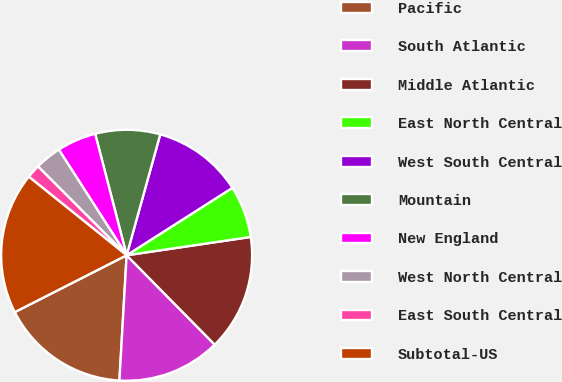Convert chart. <chart><loc_0><loc_0><loc_500><loc_500><pie_chart><fcel>Pacific<fcel>South Atlantic<fcel>Middle Atlantic<fcel>East North Central<fcel>West South Central<fcel>Mountain<fcel>New England<fcel>West North Central<fcel>East South Central<fcel>Subtotal-US<nl><fcel>16.6%<fcel>13.3%<fcel>14.95%<fcel>6.7%<fcel>11.65%<fcel>8.35%<fcel>5.05%<fcel>3.4%<fcel>1.75%<fcel>18.25%<nl></chart> 